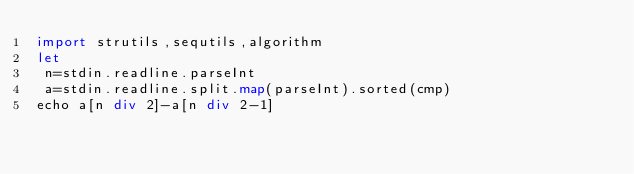<code> <loc_0><loc_0><loc_500><loc_500><_Nim_>import strutils,sequtils,algorithm
let
 n=stdin.readline.parseInt
 a=stdin.readline.split.map(parseInt).sorted(cmp)
echo a[n div 2]-a[n div 2-1]</code> 